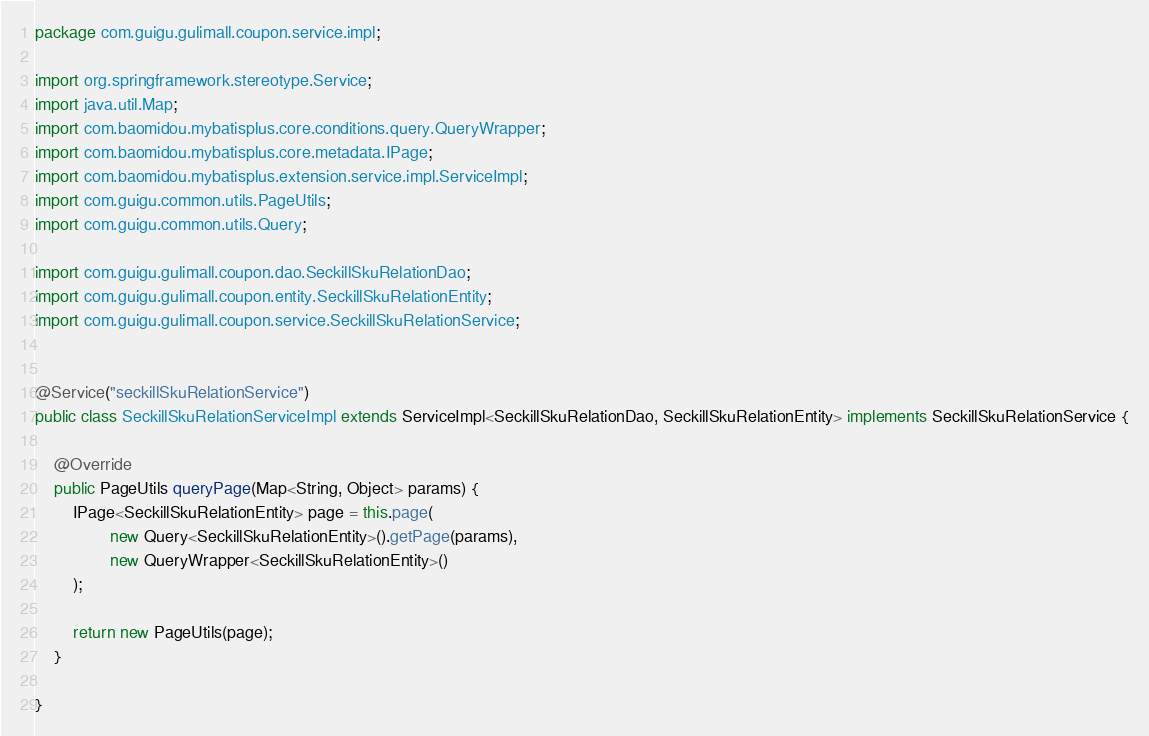Convert code to text. <code><loc_0><loc_0><loc_500><loc_500><_Java_>package com.guigu.gulimall.coupon.service.impl;

import org.springframework.stereotype.Service;
import java.util.Map;
import com.baomidou.mybatisplus.core.conditions.query.QueryWrapper;
import com.baomidou.mybatisplus.core.metadata.IPage;
import com.baomidou.mybatisplus.extension.service.impl.ServiceImpl;
import com.guigu.common.utils.PageUtils;
import com.guigu.common.utils.Query;

import com.guigu.gulimall.coupon.dao.SeckillSkuRelationDao;
import com.guigu.gulimall.coupon.entity.SeckillSkuRelationEntity;
import com.guigu.gulimall.coupon.service.SeckillSkuRelationService;


@Service("seckillSkuRelationService")
public class SeckillSkuRelationServiceImpl extends ServiceImpl<SeckillSkuRelationDao, SeckillSkuRelationEntity> implements SeckillSkuRelationService {

    @Override
    public PageUtils queryPage(Map<String, Object> params) {
        IPage<SeckillSkuRelationEntity> page = this.page(
                new Query<SeckillSkuRelationEntity>().getPage(params),
                new QueryWrapper<SeckillSkuRelationEntity>()
        );

        return new PageUtils(page);
    }

}</code> 